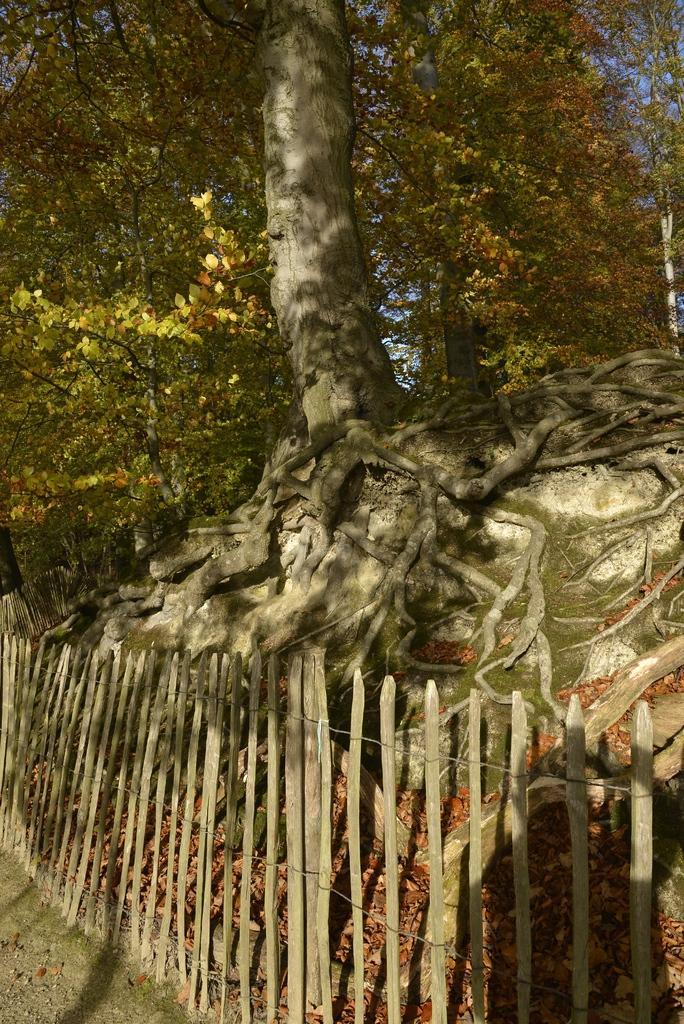Please provide a concise description of this image. In this image we can see there is a huge tree. In front of the tree there is a fencing with wooden sticks. 